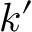<formula> <loc_0><loc_0><loc_500><loc_500>k ^ { \prime }</formula> 